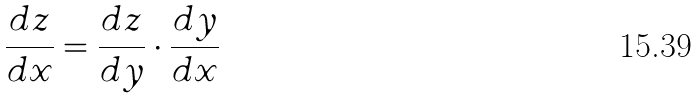Convert formula to latex. <formula><loc_0><loc_0><loc_500><loc_500>\frac { d z } { d x } = \frac { d z } { d y } \cdot \frac { d y } { d x }</formula> 